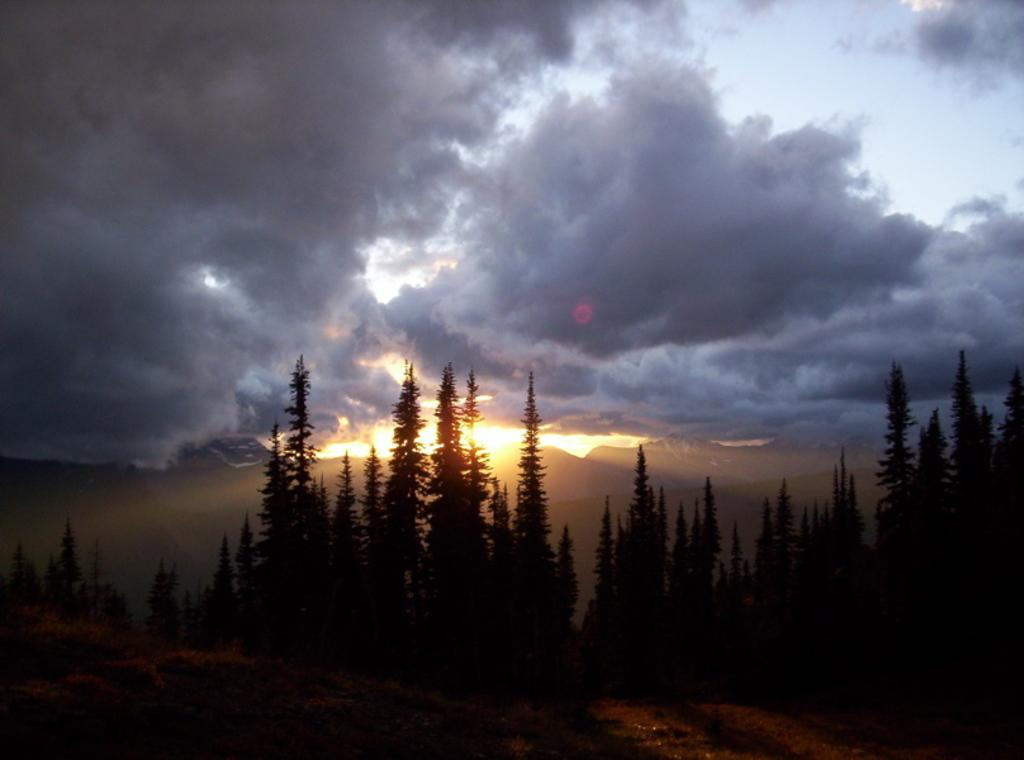What is the main feature of the dark area in the image? Trees are present in the dark area. What can be seen in the background of the image? Hills are visible in the background. Can you describe the lighting conditions in the image? Sunlight is present in the image, but the sky is cloudy. What type of mask is the queen wearing in the image? There is no queen or mask present in the image. 